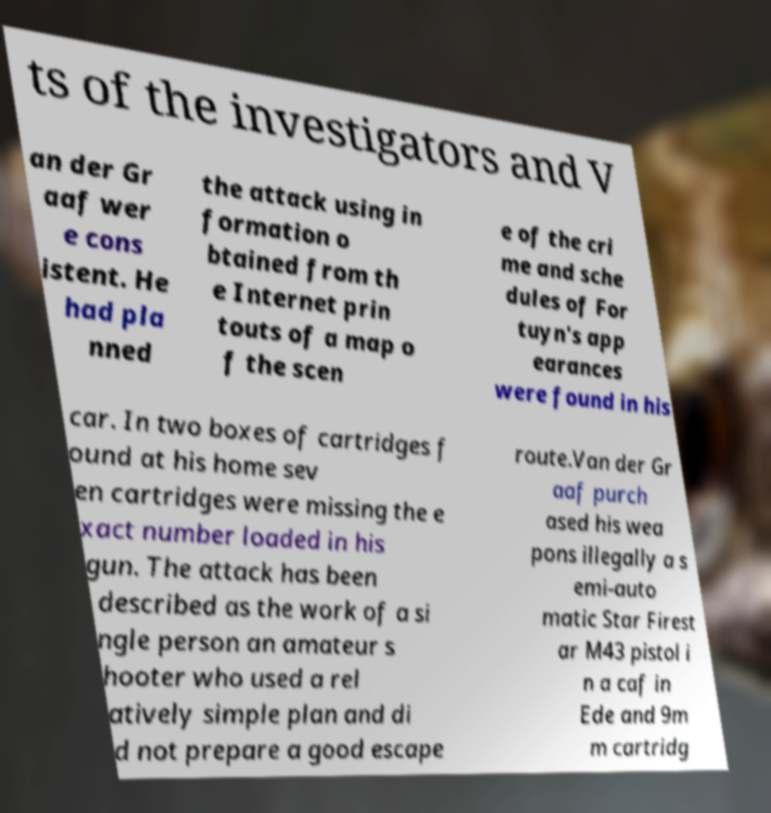What messages or text are displayed in this image? I need them in a readable, typed format. ts of the investigators and V an der Gr aaf wer e cons istent. He had pla nned the attack using in formation o btained from th e Internet prin touts of a map o f the scen e of the cri me and sche dules of For tuyn's app earances were found in his car. In two boxes of cartridges f ound at his home sev en cartridges were missing the e xact number loaded in his gun. The attack has been described as the work of a si ngle person an amateur s hooter who used a rel atively simple plan and di d not prepare a good escape route.Van der Gr aaf purch ased his wea pons illegally a s emi-auto matic Star Firest ar M43 pistol i n a caf in Ede and 9m m cartridg 